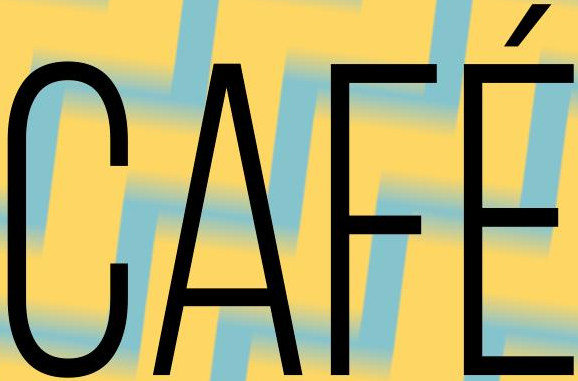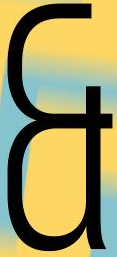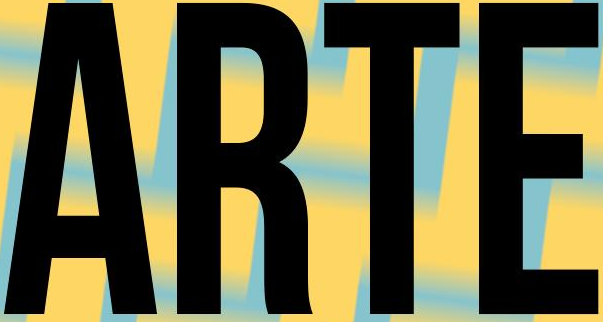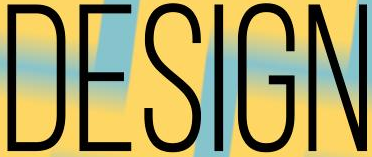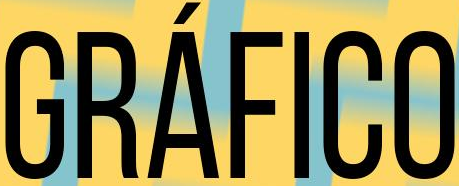What text is displayed in these images sequentially, separated by a semicolon? CAFÉ; &; ARTE; DESIGN; GRÁFICO 